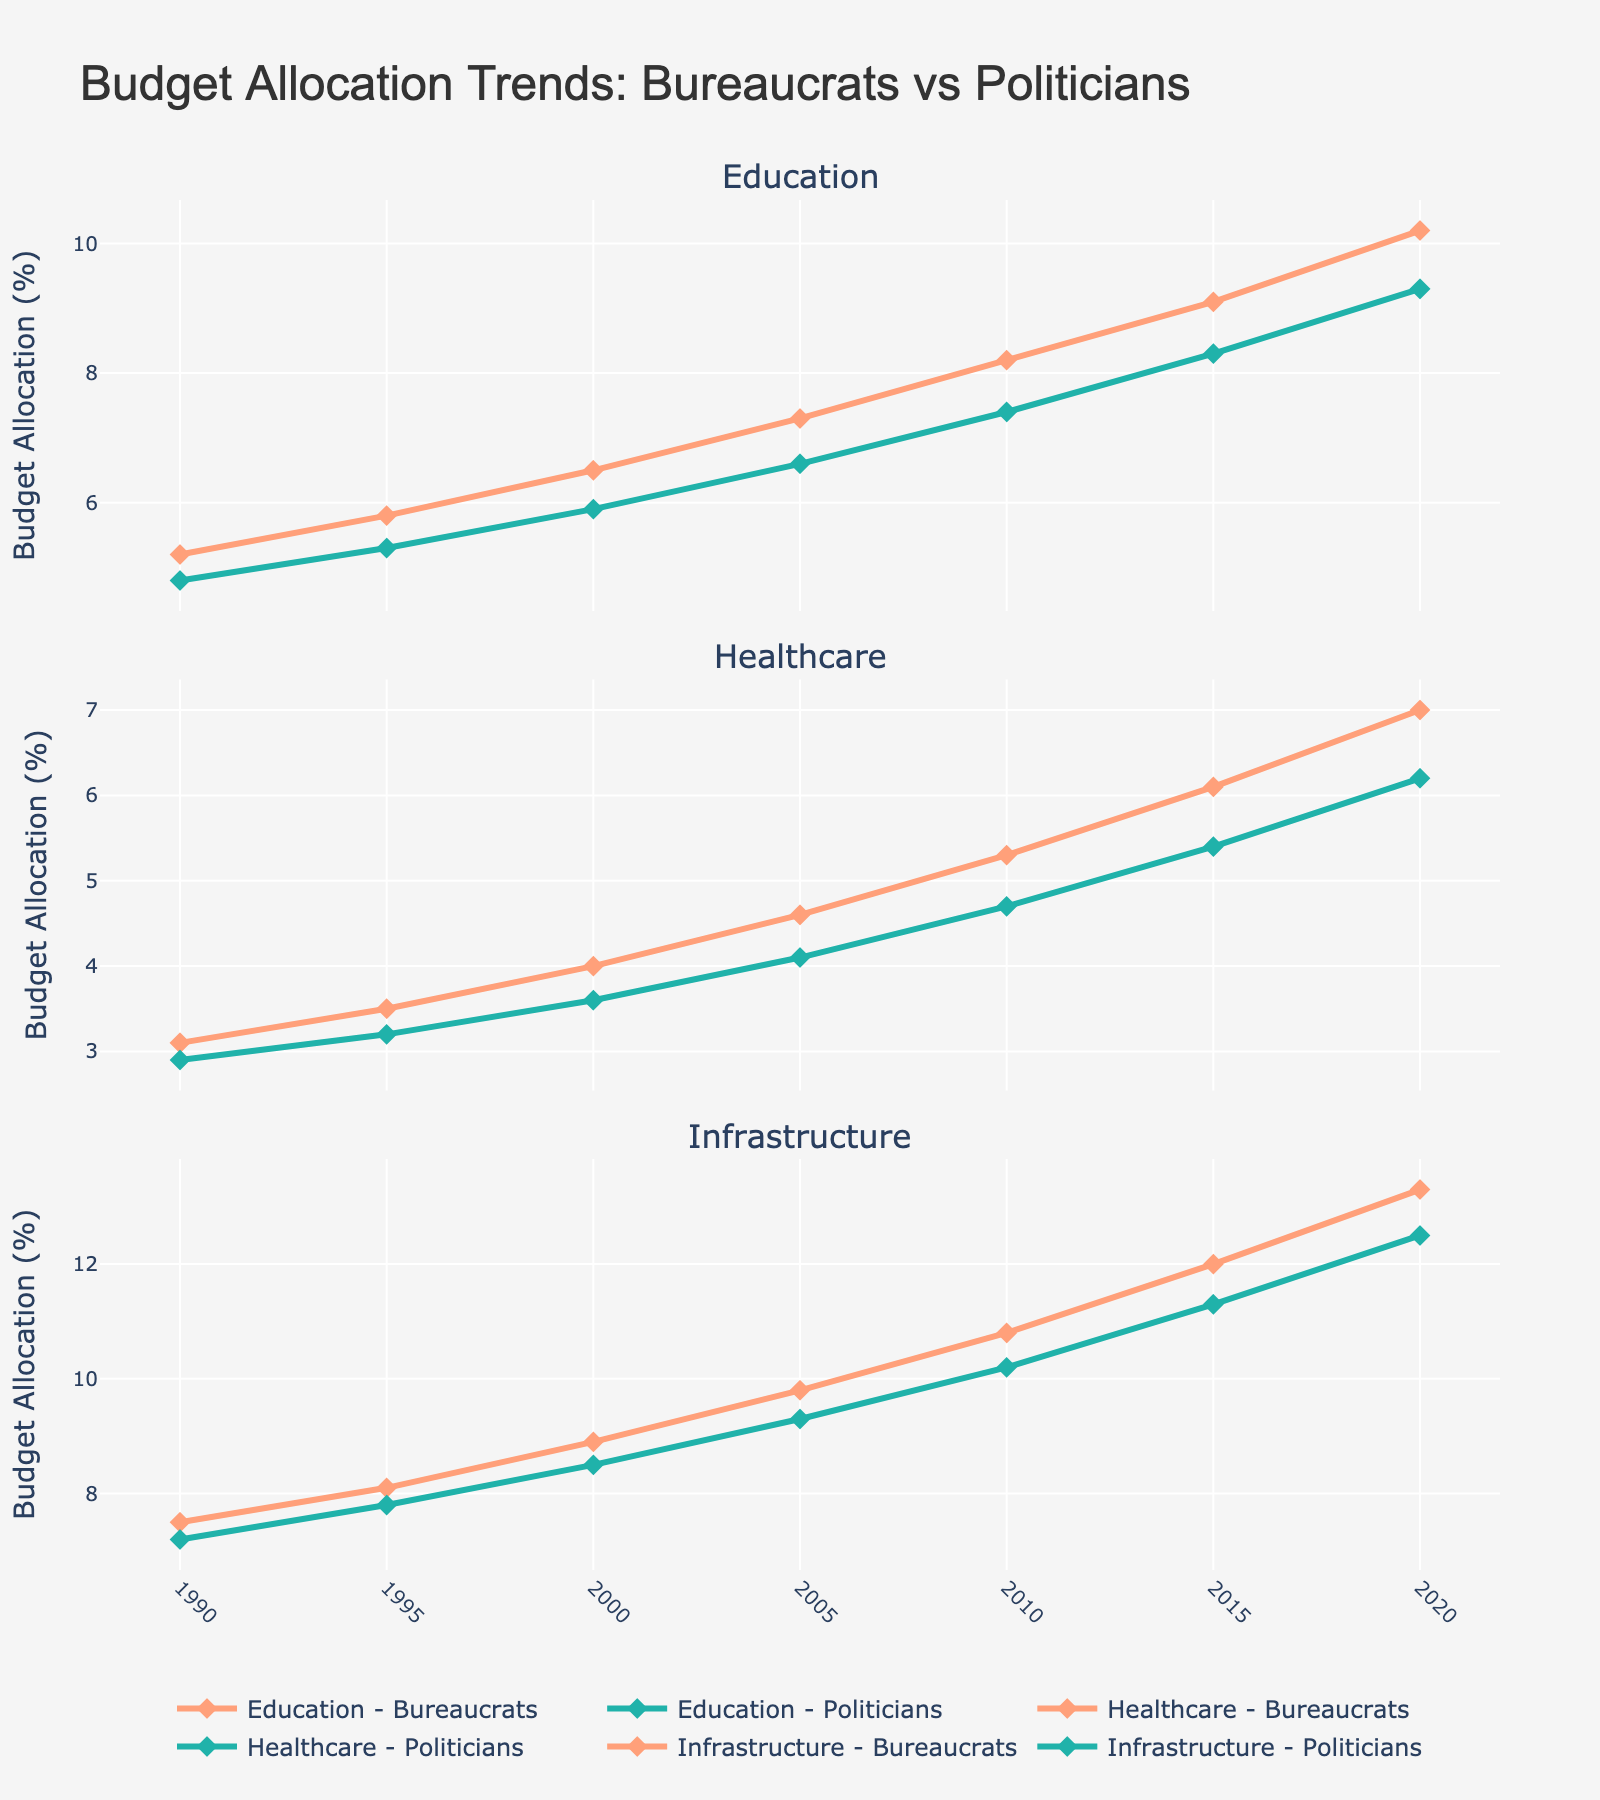What is the trend in budget allocation for education in states governed by bureaucrats over the last 30 years? The line chart shows that the budget allocation for education in states governed by bureaucrats has steadily increased from 5.2% in 1990 to 10.2% in 2020.
Answer: It has steadily increased How does the healthcare budget allocation in 2000 compare between states governed by bureaucrats and those governed by politicians? From the chart, the healthcare budget allocation in 2000 is 4.0% in states governed by bureaucrats and 3.6% in states governed by politicians. The allocation is higher in states governed by bureaucrats.
Answer: Higher in states governed by bureaucrats Which sector shows the greatest difference in budget allocation between bureaucrats and politicians by 2020? By 2020, the difference in budget allocation for the healthcare sector is 0.8%, while for education it is 0.9%, and for infrastructure, it is 0.8%. Thus, education shows the greatest difference.
Answer: Education What is the average budget allocation for healthcare in states governed by politicians between 1990 and 2020? Summing up the allocations for healthcare in states governed by politicians from 1990 to 2020: (2.9 + 3.2 + 3.6 + 4.1 + 4.7 + 5.4 + 6.2) = 30.1. There are 7 data points, so the average is 30.1 / 7.
Answer: 4.3% What year does the education budget allocation for states governed by politicians first exceed 7%? Referring to the chart, the education budget allocation for states governed by politicians first exceeds 7% in 2010.
Answer: 2010 What is the combined budget allocation for education and infrastructure by politicians in 2015? Adding the education budget allocation (8.3%) and infrastructure budget allocation (11.3%) for politicians in 2015 gives: 8.3 + 11.3 = 19.6%.
Answer: 19.6% By how much did the infrastructure budget allocation change from 1990 to 2020 in states governed by bureaucrats? From the chart, the infrastructure budget allocation in states governed by bureaucrats increased from 7.5% in 1990 to 13.3% in 2020. The change is 13.3 - 7.5 = 5.8%.
Answer: 5.8% How does the trend in healthcare budget allocation compare between bureaucrats and politicians from 1990 to 2020? From the chart, both lines show an increasing trend. However, the healthcare budget allocation by bureaucrats shows a more significant increase from 3.1% to 7.0% while for politicians, it increases from 2.9% to 6.2%.
Answer: Both are increasing, but more sharply for bureaucrats What is the total increase in education budget allocation for bureaucrats from 1990 to 2015? The increase from 1990 (5.2%) to 2015 (9.1%) is 9.1 - 5.2 = 3.9%.
Answer: 3.9% In which year did states governed by bureaucrats reach a budget allocation of over 8% for infrastructure? According to the chart, states governed by bureaucrats first reached over 8% for infrastructure budget allocation in the year 2000.
Answer: 2000 